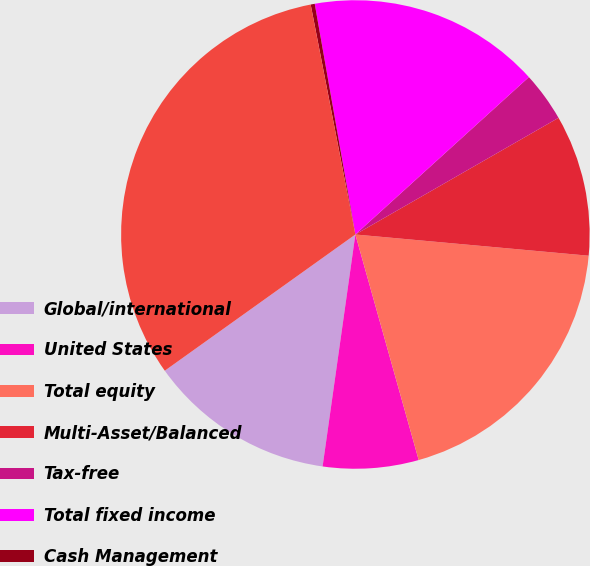Convert chart. <chart><loc_0><loc_0><loc_500><loc_500><pie_chart><fcel>Global/international<fcel>United States<fcel>Total equity<fcel>Multi-Asset/Balanced<fcel>Tax-free<fcel>Total fixed income<fcel>Cash Management<fcel>Total<nl><fcel>12.89%<fcel>6.59%<fcel>19.2%<fcel>9.74%<fcel>3.43%<fcel>16.05%<fcel>0.28%<fcel>31.82%<nl></chart> 